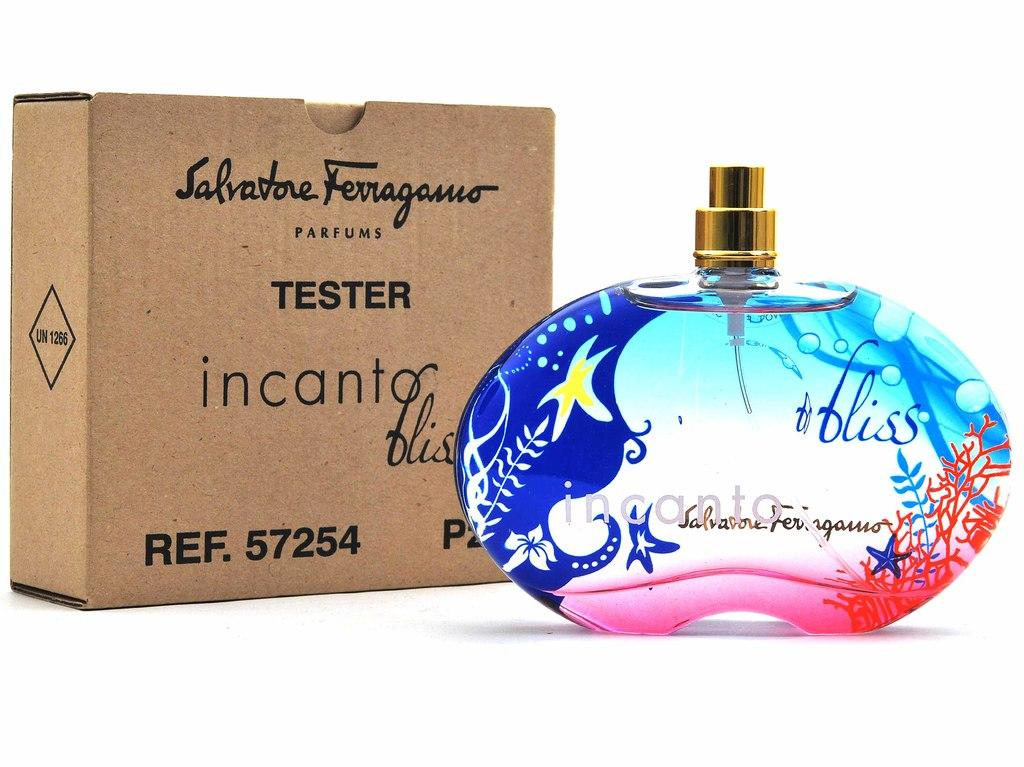<image>
Present a compact description of the photo's key features. A colorful bottle of incanto perfume sits next to the box it came in. 